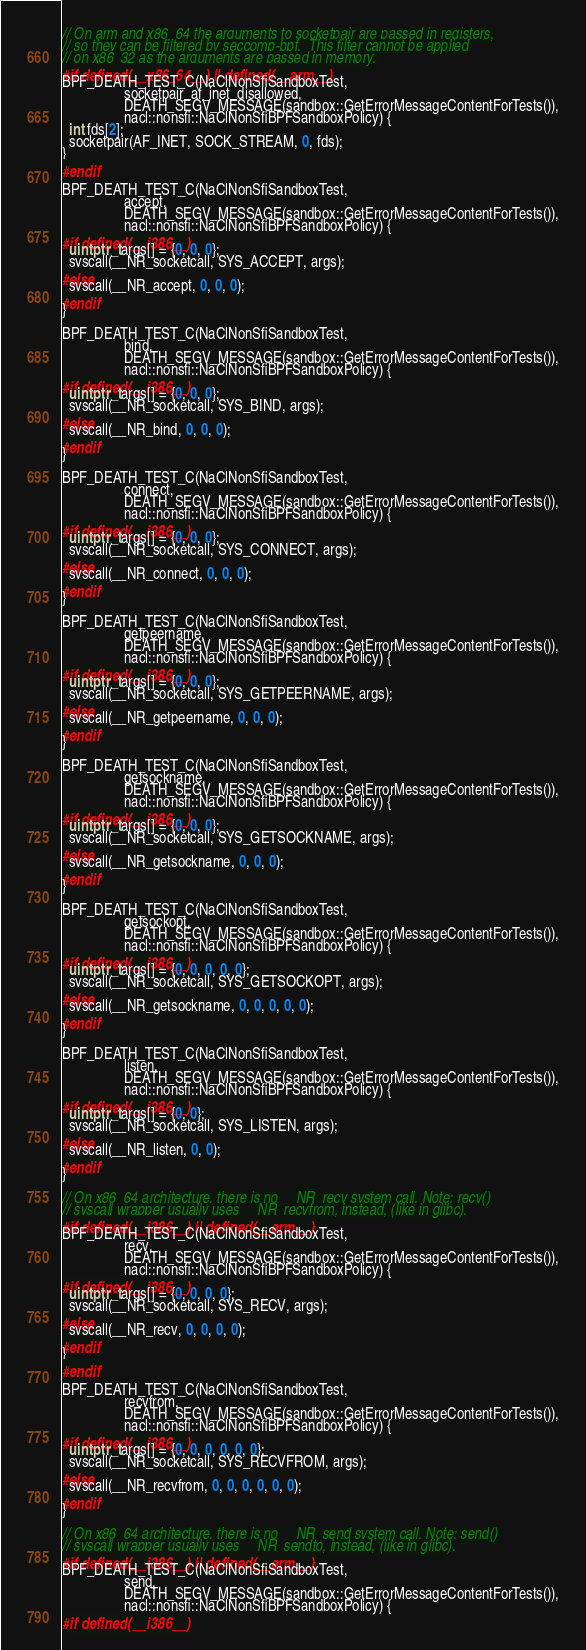Convert code to text. <code><loc_0><loc_0><loc_500><loc_500><_C++_>// On arm and x86_64 the arguments to socketpair are passed in registers,
// so they can be filtered by seccomp-bpf.  This filter cannot be applied
// on x86_32 as the arguments are passed in memory.
#if defined(__x86_64__) || defined(__arm__)
BPF_DEATH_TEST_C(NaClNonSfiSandboxTest,
                 socketpair_af_inet_disallowed,
                 DEATH_SEGV_MESSAGE(sandbox::GetErrorMessageContentForTests()),
                 nacl::nonsfi::NaClNonSfiBPFSandboxPolicy) {
  int fds[2];
  socketpair(AF_INET, SOCK_STREAM, 0, fds);
}
#endif

BPF_DEATH_TEST_C(NaClNonSfiSandboxTest,
                 accept,
                 DEATH_SEGV_MESSAGE(sandbox::GetErrorMessageContentForTests()),
                 nacl::nonsfi::NaClNonSfiBPFSandboxPolicy) {
#if defined(__i386__)
  uintptr_t args[] = {0, 0, 0};
  syscall(__NR_socketcall, SYS_ACCEPT, args);
#else
  syscall(__NR_accept, 0, 0, 0);
#endif
}

BPF_DEATH_TEST_C(NaClNonSfiSandboxTest,
                 bind,
                 DEATH_SEGV_MESSAGE(sandbox::GetErrorMessageContentForTests()),
                 nacl::nonsfi::NaClNonSfiBPFSandboxPolicy) {
#if defined(__i386__)
  uintptr_t args[] = {0, 0, 0};
  syscall(__NR_socketcall, SYS_BIND, args);
#else
  syscall(__NR_bind, 0, 0, 0);
#endif
}

BPF_DEATH_TEST_C(NaClNonSfiSandboxTest,
                 connect,
                 DEATH_SEGV_MESSAGE(sandbox::GetErrorMessageContentForTests()),
                 nacl::nonsfi::NaClNonSfiBPFSandboxPolicy) {
#if defined(__i386__)
  uintptr_t args[] = {0, 0, 0};
  syscall(__NR_socketcall, SYS_CONNECT, args);
#else
  syscall(__NR_connect, 0, 0, 0);
#endif
}

BPF_DEATH_TEST_C(NaClNonSfiSandboxTest,
                 getpeername,
                 DEATH_SEGV_MESSAGE(sandbox::GetErrorMessageContentForTests()),
                 nacl::nonsfi::NaClNonSfiBPFSandboxPolicy) {
#if defined(__i386__)
  uintptr_t args[] = {0, 0, 0};
  syscall(__NR_socketcall, SYS_GETPEERNAME, args);
#else
  syscall(__NR_getpeername, 0, 0, 0);
#endif
}

BPF_DEATH_TEST_C(NaClNonSfiSandboxTest,
                 getsockname,
                 DEATH_SEGV_MESSAGE(sandbox::GetErrorMessageContentForTests()),
                 nacl::nonsfi::NaClNonSfiBPFSandboxPolicy) {
#if defined(__i386__)
  uintptr_t args[] = {0, 0, 0};
  syscall(__NR_socketcall, SYS_GETSOCKNAME, args);
#else
  syscall(__NR_getsockname, 0, 0, 0);
#endif
}

BPF_DEATH_TEST_C(NaClNonSfiSandboxTest,
                 getsockopt,
                 DEATH_SEGV_MESSAGE(sandbox::GetErrorMessageContentForTests()),
                 nacl::nonsfi::NaClNonSfiBPFSandboxPolicy) {
#if defined(__i386__)
  uintptr_t args[] = {0, 0, 0, 0, 0};
  syscall(__NR_socketcall, SYS_GETSOCKOPT, args);
#else
  syscall(__NR_getsockname, 0, 0, 0, 0, 0);
#endif
}

BPF_DEATH_TEST_C(NaClNonSfiSandboxTest,
                 listen,
                 DEATH_SEGV_MESSAGE(sandbox::GetErrorMessageContentForTests()),
                 nacl::nonsfi::NaClNonSfiBPFSandboxPolicy) {
#if defined(__i386__)
  uintptr_t args[] = {0, 0};
  syscall(__NR_socketcall, SYS_LISTEN, args);
#else
  syscall(__NR_listen, 0, 0);
#endif
}

// On x86_64 architecture, there is no __NR_recv system call. Note: recv()
// syscall wrapper usually uses __NR_recvfrom, instead, (like in glibc).
#if defined(__i386__) || defined(__arm__)
BPF_DEATH_TEST_C(NaClNonSfiSandboxTest,
                 recv,
                 DEATH_SEGV_MESSAGE(sandbox::GetErrorMessageContentForTests()),
                 nacl::nonsfi::NaClNonSfiBPFSandboxPolicy) {
#if defined(__i386__)
  uintptr_t args[] = {0, 0, 0, 0};
  syscall(__NR_socketcall, SYS_RECV, args);
#else
  syscall(__NR_recv, 0, 0, 0, 0);
#endif
}
#endif

BPF_DEATH_TEST_C(NaClNonSfiSandboxTest,
                 recvfrom,
                 DEATH_SEGV_MESSAGE(sandbox::GetErrorMessageContentForTests()),
                 nacl::nonsfi::NaClNonSfiBPFSandboxPolicy) {
#if defined(__i386__)
  uintptr_t args[] = {0, 0, 0, 0, 0, 0};
  syscall(__NR_socketcall, SYS_RECVFROM, args);
#else
  syscall(__NR_recvfrom, 0, 0, 0, 0, 0, 0);
#endif
}

// On x86_64 architecture, there is no __NR_send system call. Note: send()
// syscall wrapper usually uses __NR_sendto, instead, (like in glibc).
#if defined(__i386__) || defined(__arm__)
BPF_DEATH_TEST_C(NaClNonSfiSandboxTest,
                 send,
                 DEATH_SEGV_MESSAGE(sandbox::GetErrorMessageContentForTests()),
                 nacl::nonsfi::NaClNonSfiBPFSandboxPolicy) {
#if defined(__i386__)</code> 